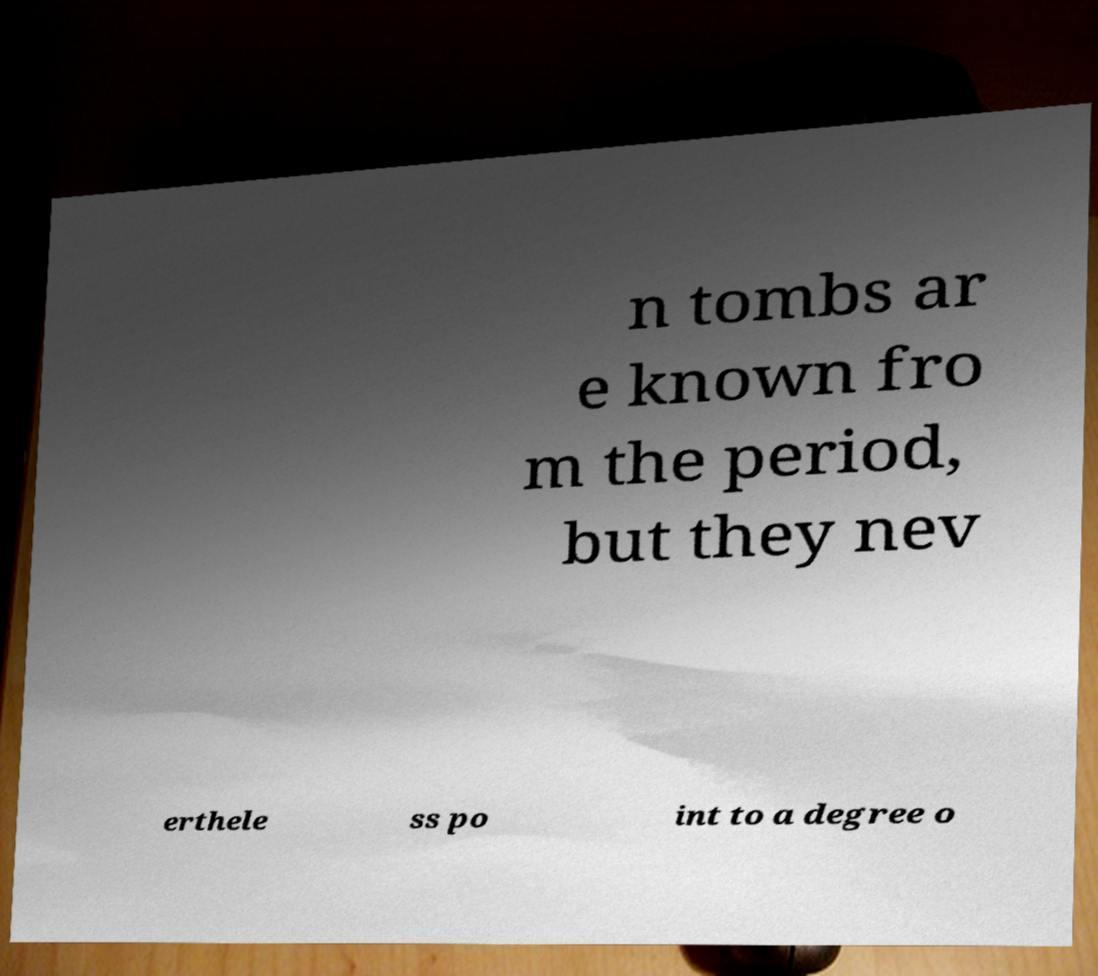For documentation purposes, I need the text within this image transcribed. Could you provide that? n tombs ar e known fro m the period, but they nev erthele ss po int to a degree o 